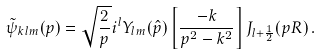<formula> <loc_0><loc_0><loc_500><loc_500>\tilde { \psi } _ { k l m } ( { p } ) = \sqrt { \frac { 2 } { p } } i ^ { l } Y _ { l m } ( \hat { p } ) \left [ \frac { - k } { p ^ { 2 } - k ^ { 2 } } \right ] J _ { l + \frac { 1 } { 2 } } ( p R ) \, .</formula> 